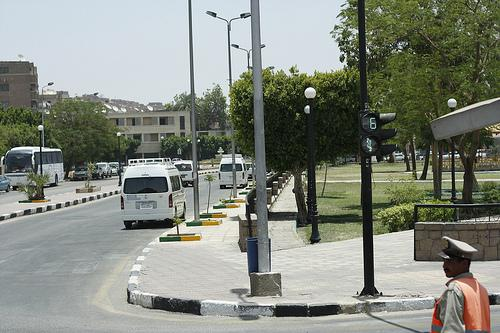Question: what is the weather?
Choices:
A. Dark and stormy.
B. Overcast.
C. Sunny.
D. Cloudy.
Answer with the letter. Answer: C Question: how is the photo?
Choices:
A. Blurry.
B. Clear.
C. Cropped.
D. Sharp.
Answer with the letter. Answer: B 